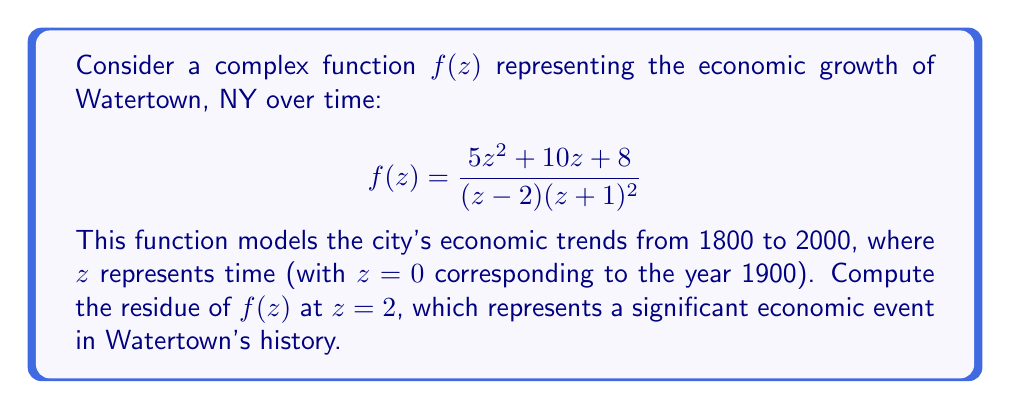Provide a solution to this math problem. To find the residue of $f(z)$ at $z=2$, we need to analyze the behavior of the function near this point. Since $z=2$ is a simple pole of $f(z)$, we can use the formula for the residue at a simple pole:

$$\text{Res}(f,2) = \lim_{z \to 2} (z-2)f(z)$$

Let's evaluate this limit step by step:

1) First, let's simplify the numerator of $f(z)$:
   $$f(z) = \frac{5z^2 + 10z + 8}{(z-2)(z+1)^2}$$

2) Now, let's multiply the numerator and denominator by $(z-2)$:
   $$\text{Res}(f,2) = \lim_{z \to 2} \frac{(z-2)(5z^2 + 10z + 8)}{(z-2)^2(z+1)^2}$$

3) The $(z-2)$ terms cancel out:
   $$\text{Res}(f,2) = \lim_{z \to 2} \frac{5z^2 + 10z + 8}{(z-2)(z+1)^2}$$

4) Now we can directly substitute $z=2$:
   $$\text{Res}(f,2) = \frac{5(2)^2 + 10(2) + 8}{(2-2)(2+1)^2} = \frac{20 + 20 + 8}{0 \cdot 9}$$

5) Simplify the numerator:
   $$\text{Res}(f,2) = \frac{48}{0 \cdot 9} = \frac{48}{0}$$

6) The denominator is zero, but this is expected as we're dealing with a limit. The actual value is the numerator divided by the coefficient of $(z-2)$ in the denominator when $z=2$. The denominator can be rewritten as:
   $$(z-2)(z+1)^2 = (z-2)(z^2 + 2z + 1)$$
   When $z=2$, the coefficient of $(z-2)$ is $(2^2 + 2(2) + 1) = 9$

7) Therefore, the residue is:
   $$\text{Res}(f,2) = \frac{48}{9} = \frac{16}{3}$$

This value represents the strength of the economic event at the year 1920 (since $z=2$ corresponds to 20 years after 1900) in Watertown's history.
Answer: The residue of $f(z)$ at $z=2$ is $\frac{16}{3}$. 